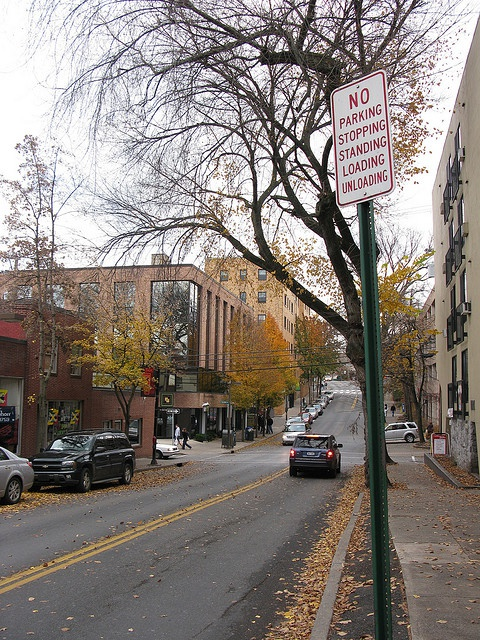Describe the objects in this image and their specific colors. I can see car in white, black, gray, darkgray, and lightgray tones, car in white, black, gray, darkgray, and maroon tones, car in white, gray, black, and darkgray tones, car in white, gray, black, darkgray, and lightgray tones, and car in white, darkgray, lightgray, gray, and black tones in this image. 